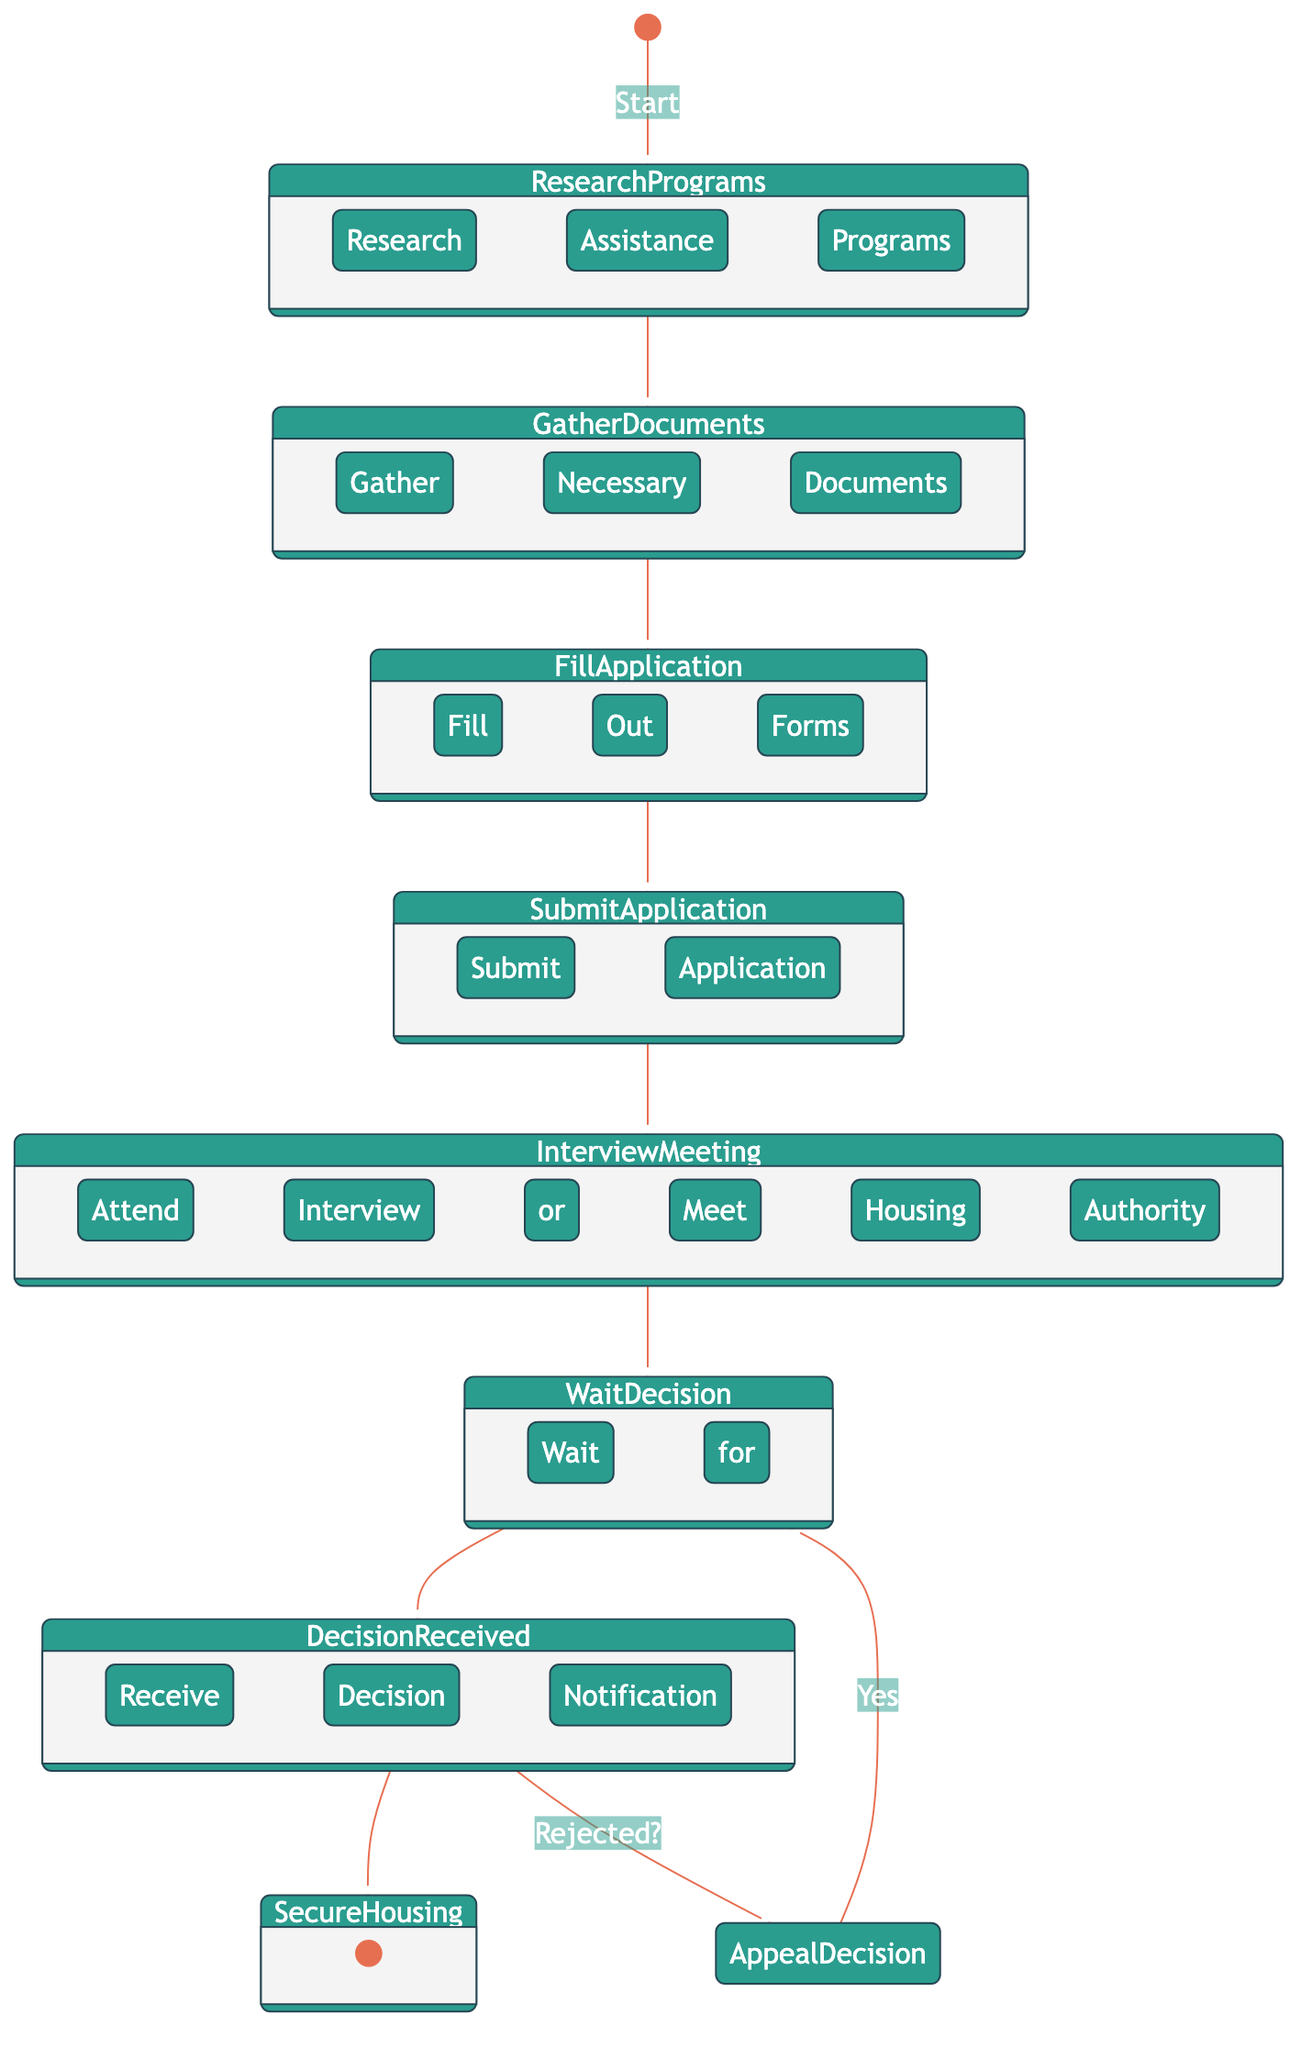What is the first step in the process? The first step in the process is represented by the "Start" node. From this node, the flow goes to "Research Housing Assistance Programs."
Answer: Start How many nodes are there in the diagram? By counting all the nodes in the diagram, we find there are a total of 9 nodes: the start node, 7 activities, and the end node.
Answer: 9 What happens after attending the interview? After attending the interview, the next step is to "Wait for Decision," which is indicated as the subsequent node in the flow diagram.
Answer: Wait for Decision What decision can a person make after receiving a decision notification? After receiving a decision notification, if the application is rejected, a person can choose to "Appeal Decision if Necessary," as indicated by the decision node branching out from the "Decision Received" node.
Answer: Appeal Decision if Necessary If the decision is to appeal, where does the flow go next? If the decision is to appeal, the flow goes back to "Wait for Decision," indicating that the process starts over at this stage until a new decision is received.
Answer: Wait for Decision How many activities are involved in the application process? The diagram shows 6 activities: "Research Housing Assistance Programs," "Gather Necessary Documents," "Fill Out Application Forms," "Submit Application," "Attend Interview or Meet Housing Authority," and "Wait for Decision."
Answer: 6 What is the final step in the process? The final step in the process, indicated by the end node, is "Secure Housing." This is the last activity that can occur after the decision has been received and is positive.
Answer: Secure Housing What occurs if the application is accepted? If the application is accepted (i.e., not rejected), the next step is "Secure Housing," which means the process concludes successfully at that point.
Answer: Secure Housing 